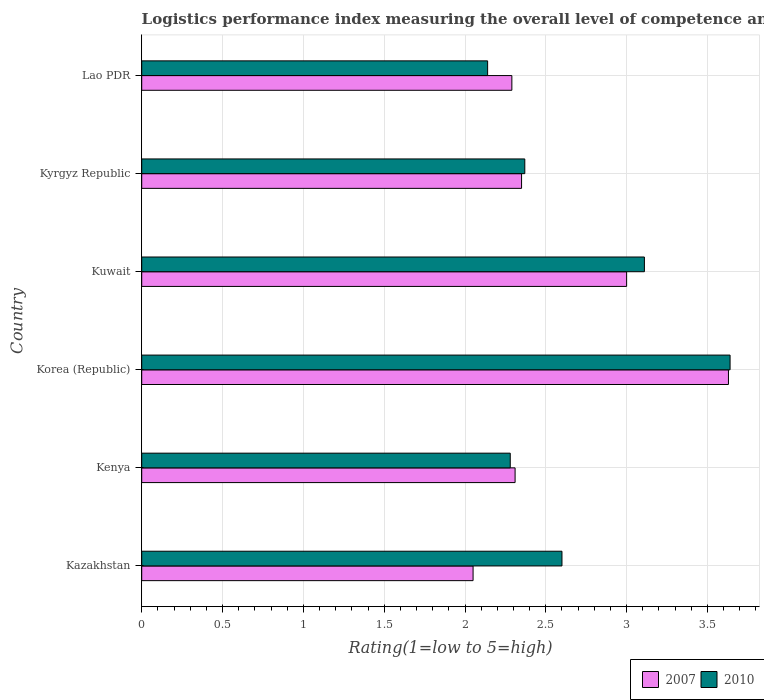How many different coloured bars are there?
Give a very brief answer. 2. Are the number of bars per tick equal to the number of legend labels?
Ensure brevity in your answer.  Yes. Are the number of bars on each tick of the Y-axis equal?
Your response must be concise. Yes. How many bars are there on the 3rd tick from the top?
Offer a very short reply. 2. How many bars are there on the 2nd tick from the bottom?
Provide a short and direct response. 2. What is the label of the 2nd group of bars from the top?
Your response must be concise. Kyrgyz Republic. In how many cases, is the number of bars for a given country not equal to the number of legend labels?
Offer a very short reply. 0. What is the Logistic performance index in 2007 in Korea (Republic)?
Offer a terse response. 3.63. Across all countries, what is the maximum Logistic performance index in 2010?
Give a very brief answer. 3.64. Across all countries, what is the minimum Logistic performance index in 2010?
Your answer should be compact. 2.14. In which country was the Logistic performance index in 2007 minimum?
Provide a short and direct response. Kazakhstan. What is the total Logistic performance index in 2010 in the graph?
Make the answer very short. 16.14. What is the difference between the Logistic performance index in 2007 in Kazakhstan and that in Korea (Republic)?
Offer a very short reply. -1.58. What is the difference between the Logistic performance index in 2010 in Kuwait and the Logistic performance index in 2007 in Lao PDR?
Your answer should be very brief. 0.82. What is the average Logistic performance index in 2010 per country?
Make the answer very short. 2.69. What is the difference between the Logistic performance index in 2007 and Logistic performance index in 2010 in Lao PDR?
Make the answer very short. 0.15. In how many countries, is the Logistic performance index in 2010 greater than 2.6 ?
Provide a short and direct response. 2. What is the ratio of the Logistic performance index in 2010 in Korea (Republic) to that in Kuwait?
Offer a terse response. 1.17. Is the difference between the Logistic performance index in 2007 in Korea (Republic) and Kuwait greater than the difference between the Logistic performance index in 2010 in Korea (Republic) and Kuwait?
Ensure brevity in your answer.  Yes. What is the difference between the highest and the second highest Logistic performance index in 2007?
Give a very brief answer. 0.63. What does the 1st bar from the top in Kenya represents?
Give a very brief answer. 2010. What does the 1st bar from the bottom in Lao PDR represents?
Make the answer very short. 2007. Are all the bars in the graph horizontal?
Give a very brief answer. Yes. Where does the legend appear in the graph?
Offer a terse response. Bottom right. What is the title of the graph?
Give a very brief answer. Logistics performance index measuring the overall level of competence and quality of logistics services. What is the label or title of the X-axis?
Ensure brevity in your answer.  Rating(1=low to 5=high). What is the Rating(1=low to 5=high) of 2007 in Kazakhstan?
Ensure brevity in your answer.  2.05. What is the Rating(1=low to 5=high) in 2007 in Kenya?
Provide a short and direct response. 2.31. What is the Rating(1=low to 5=high) in 2010 in Kenya?
Your answer should be very brief. 2.28. What is the Rating(1=low to 5=high) in 2007 in Korea (Republic)?
Ensure brevity in your answer.  3.63. What is the Rating(1=low to 5=high) in 2010 in Korea (Republic)?
Provide a short and direct response. 3.64. What is the Rating(1=low to 5=high) of 2007 in Kuwait?
Offer a very short reply. 3. What is the Rating(1=low to 5=high) of 2010 in Kuwait?
Ensure brevity in your answer.  3.11. What is the Rating(1=low to 5=high) of 2007 in Kyrgyz Republic?
Give a very brief answer. 2.35. What is the Rating(1=low to 5=high) of 2010 in Kyrgyz Republic?
Your response must be concise. 2.37. What is the Rating(1=low to 5=high) in 2007 in Lao PDR?
Your answer should be very brief. 2.29. What is the Rating(1=low to 5=high) in 2010 in Lao PDR?
Your response must be concise. 2.14. Across all countries, what is the maximum Rating(1=low to 5=high) of 2007?
Provide a succinct answer. 3.63. Across all countries, what is the maximum Rating(1=low to 5=high) in 2010?
Make the answer very short. 3.64. Across all countries, what is the minimum Rating(1=low to 5=high) in 2007?
Make the answer very short. 2.05. Across all countries, what is the minimum Rating(1=low to 5=high) in 2010?
Keep it short and to the point. 2.14. What is the total Rating(1=low to 5=high) in 2007 in the graph?
Provide a succinct answer. 15.63. What is the total Rating(1=low to 5=high) in 2010 in the graph?
Your response must be concise. 16.14. What is the difference between the Rating(1=low to 5=high) in 2007 in Kazakhstan and that in Kenya?
Your answer should be compact. -0.26. What is the difference between the Rating(1=low to 5=high) of 2010 in Kazakhstan and that in Kenya?
Ensure brevity in your answer.  0.32. What is the difference between the Rating(1=low to 5=high) in 2007 in Kazakhstan and that in Korea (Republic)?
Your answer should be compact. -1.58. What is the difference between the Rating(1=low to 5=high) in 2010 in Kazakhstan and that in Korea (Republic)?
Offer a very short reply. -1.04. What is the difference between the Rating(1=low to 5=high) in 2007 in Kazakhstan and that in Kuwait?
Give a very brief answer. -0.95. What is the difference between the Rating(1=low to 5=high) of 2010 in Kazakhstan and that in Kuwait?
Give a very brief answer. -0.51. What is the difference between the Rating(1=low to 5=high) of 2010 in Kazakhstan and that in Kyrgyz Republic?
Your answer should be compact. 0.23. What is the difference between the Rating(1=low to 5=high) in 2007 in Kazakhstan and that in Lao PDR?
Offer a terse response. -0.24. What is the difference between the Rating(1=low to 5=high) of 2010 in Kazakhstan and that in Lao PDR?
Offer a very short reply. 0.46. What is the difference between the Rating(1=low to 5=high) in 2007 in Kenya and that in Korea (Republic)?
Provide a succinct answer. -1.32. What is the difference between the Rating(1=low to 5=high) in 2010 in Kenya and that in Korea (Republic)?
Keep it short and to the point. -1.36. What is the difference between the Rating(1=low to 5=high) of 2007 in Kenya and that in Kuwait?
Your response must be concise. -0.69. What is the difference between the Rating(1=low to 5=high) of 2010 in Kenya and that in Kuwait?
Offer a very short reply. -0.83. What is the difference between the Rating(1=low to 5=high) in 2007 in Kenya and that in Kyrgyz Republic?
Your answer should be very brief. -0.04. What is the difference between the Rating(1=low to 5=high) of 2010 in Kenya and that in Kyrgyz Republic?
Offer a very short reply. -0.09. What is the difference between the Rating(1=low to 5=high) of 2010 in Kenya and that in Lao PDR?
Keep it short and to the point. 0.14. What is the difference between the Rating(1=low to 5=high) of 2007 in Korea (Republic) and that in Kuwait?
Give a very brief answer. 0.63. What is the difference between the Rating(1=low to 5=high) in 2010 in Korea (Republic) and that in Kuwait?
Keep it short and to the point. 0.53. What is the difference between the Rating(1=low to 5=high) of 2007 in Korea (Republic) and that in Kyrgyz Republic?
Your answer should be very brief. 1.28. What is the difference between the Rating(1=low to 5=high) in 2010 in Korea (Republic) and that in Kyrgyz Republic?
Give a very brief answer. 1.27. What is the difference between the Rating(1=low to 5=high) of 2007 in Korea (Republic) and that in Lao PDR?
Offer a terse response. 1.34. What is the difference between the Rating(1=low to 5=high) of 2010 in Korea (Republic) and that in Lao PDR?
Make the answer very short. 1.5. What is the difference between the Rating(1=low to 5=high) of 2007 in Kuwait and that in Kyrgyz Republic?
Your answer should be compact. 0.65. What is the difference between the Rating(1=low to 5=high) of 2010 in Kuwait and that in Kyrgyz Republic?
Give a very brief answer. 0.74. What is the difference between the Rating(1=low to 5=high) of 2007 in Kuwait and that in Lao PDR?
Provide a succinct answer. 0.71. What is the difference between the Rating(1=low to 5=high) in 2007 in Kyrgyz Republic and that in Lao PDR?
Offer a very short reply. 0.06. What is the difference between the Rating(1=low to 5=high) in 2010 in Kyrgyz Republic and that in Lao PDR?
Give a very brief answer. 0.23. What is the difference between the Rating(1=low to 5=high) of 2007 in Kazakhstan and the Rating(1=low to 5=high) of 2010 in Kenya?
Ensure brevity in your answer.  -0.23. What is the difference between the Rating(1=low to 5=high) in 2007 in Kazakhstan and the Rating(1=low to 5=high) in 2010 in Korea (Republic)?
Your response must be concise. -1.59. What is the difference between the Rating(1=low to 5=high) of 2007 in Kazakhstan and the Rating(1=low to 5=high) of 2010 in Kuwait?
Ensure brevity in your answer.  -1.06. What is the difference between the Rating(1=low to 5=high) in 2007 in Kazakhstan and the Rating(1=low to 5=high) in 2010 in Kyrgyz Republic?
Offer a very short reply. -0.32. What is the difference between the Rating(1=low to 5=high) in 2007 in Kazakhstan and the Rating(1=low to 5=high) in 2010 in Lao PDR?
Keep it short and to the point. -0.09. What is the difference between the Rating(1=low to 5=high) in 2007 in Kenya and the Rating(1=low to 5=high) in 2010 in Korea (Republic)?
Offer a terse response. -1.33. What is the difference between the Rating(1=low to 5=high) of 2007 in Kenya and the Rating(1=low to 5=high) of 2010 in Kuwait?
Give a very brief answer. -0.8. What is the difference between the Rating(1=low to 5=high) of 2007 in Kenya and the Rating(1=low to 5=high) of 2010 in Kyrgyz Republic?
Keep it short and to the point. -0.06. What is the difference between the Rating(1=low to 5=high) of 2007 in Kenya and the Rating(1=low to 5=high) of 2010 in Lao PDR?
Ensure brevity in your answer.  0.17. What is the difference between the Rating(1=low to 5=high) in 2007 in Korea (Republic) and the Rating(1=low to 5=high) in 2010 in Kuwait?
Provide a short and direct response. 0.52. What is the difference between the Rating(1=low to 5=high) in 2007 in Korea (Republic) and the Rating(1=low to 5=high) in 2010 in Kyrgyz Republic?
Provide a succinct answer. 1.26. What is the difference between the Rating(1=low to 5=high) in 2007 in Korea (Republic) and the Rating(1=low to 5=high) in 2010 in Lao PDR?
Give a very brief answer. 1.49. What is the difference between the Rating(1=low to 5=high) in 2007 in Kuwait and the Rating(1=low to 5=high) in 2010 in Kyrgyz Republic?
Keep it short and to the point. 0.63. What is the difference between the Rating(1=low to 5=high) of 2007 in Kuwait and the Rating(1=low to 5=high) of 2010 in Lao PDR?
Offer a very short reply. 0.86. What is the difference between the Rating(1=low to 5=high) of 2007 in Kyrgyz Republic and the Rating(1=low to 5=high) of 2010 in Lao PDR?
Your answer should be very brief. 0.21. What is the average Rating(1=low to 5=high) in 2007 per country?
Offer a very short reply. 2.6. What is the average Rating(1=low to 5=high) of 2010 per country?
Ensure brevity in your answer.  2.69. What is the difference between the Rating(1=low to 5=high) of 2007 and Rating(1=low to 5=high) of 2010 in Kazakhstan?
Your answer should be very brief. -0.55. What is the difference between the Rating(1=low to 5=high) in 2007 and Rating(1=low to 5=high) in 2010 in Korea (Republic)?
Keep it short and to the point. -0.01. What is the difference between the Rating(1=low to 5=high) in 2007 and Rating(1=low to 5=high) in 2010 in Kuwait?
Your answer should be very brief. -0.11. What is the difference between the Rating(1=low to 5=high) of 2007 and Rating(1=low to 5=high) of 2010 in Kyrgyz Republic?
Ensure brevity in your answer.  -0.02. What is the difference between the Rating(1=low to 5=high) of 2007 and Rating(1=low to 5=high) of 2010 in Lao PDR?
Make the answer very short. 0.15. What is the ratio of the Rating(1=low to 5=high) of 2007 in Kazakhstan to that in Kenya?
Provide a succinct answer. 0.89. What is the ratio of the Rating(1=low to 5=high) of 2010 in Kazakhstan to that in Kenya?
Provide a succinct answer. 1.14. What is the ratio of the Rating(1=low to 5=high) of 2007 in Kazakhstan to that in Korea (Republic)?
Your response must be concise. 0.56. What is the ratio of the Rating(1=low to 5=high) of 2010 in Kazakhstan to that in Korea (Republic)?
Offer a very short reply. 0.71. What is the ratio of the Rating(1=low to 5=high) in 2007 in Kazakhstan to that in Kuwait?
Your response must be concise. 0.68. What is the ratio of the Rating(1=low to 5=high) of 2010 in Kazakhstan to that in Kuwait?
Provide a succinct answer. 0.84. What is the ratio of the Rating(1=low to 5=high) in 2007 in Kazakhstan to that in Kyrgyz Republic?
Your answer should be compact. 0.87. What is the ratio of the Rating(1=low to 5=high) of 2010 in Kazakhstan to that in Kyrgyz Republic?
Your answer should be compact. 1.1. What is the ratio of the Rating(1=low to 5=high) in 2007 in Kazakhstan to that in Lao PDR?
Provide a short and direct response. 0.9. What is the ratio of the Rating(1=low to 5=high) of 2010 in Kazakhstan to that in Lao PDR?
Your response must be concise. 1.22. What is the ratio of the Rating(1=low to 5=high) of 2007 in Kenya to that in Korea (Republic)?
Your answer should be compact. 0.64. What is the ratio of the Rating(1=low to 5=high) in 2010 in Kenya to that in Korea (Republic)?
Provide a succinct answer. 0.63. What is the ratio of the Rating(1=low to 5=high) in 2007 in Kenya to that in Kuwait?
Your answer should be very brief. 0.77. What is the ratio of the Rating(1=low to 5=high) of 2010 in Kenya to that in Kuwait?
Provide a short and direct response. 0.73. What is the ratio of the Rating(1=low to 5=high) of 2007 in Kenya to that in Kyrgyz Republic?
Provide a short and direct response. 0.98. What is the ratio of the Rating(1=low to 5=high) in 2007 in Kenya to that in Lao PDR?
Provide a short and direct response. 1.01. What is the ratio of the Rating(1=low to 5=high) in 2010 in Kenya to that in Lao PDR?
Provide a short and direct response. 1.07. What is the ratio of the Rating(1=low to 5=high) of 2007 in Korea (Republic) to that in Kuwait?
Offer a terse response. 1.21. What is the ratio of the Rating(1=low to 5=high) of 2010 in Korea (Republic) to that in Kuwait?
Your answer should be very brief. 1.17. What is the ratio of the Rating(1=low to 5=high) of 2007 in Korea (Republic) to that in Kyrgyz Republic?
Your answer should be compact. 1.54. What is the ratio of the Rating(1=low to 5=high) of 2010 in Korea (Republic) to that in Kyrgyz Republic?
Your answer should be compact. 1.54. What is the ratio of the Rating(1=low to 5=high) of 2007 in Korea (Republic) to that in Lao PDR?
Give a very brief answer. 1.59. What is the ratio of the Rating(1=low to 5=high) of 2010 in Korea (Republic) to that in Lao PDR?
Give a very brief answer. 1.7. What is the ratio of the Rating(1=low to 5=high) of 2007 in Kuwait to that in Kyrgyz Republic?
Your answer should be very brief. 1.28. What is the ratio of the Rating(1=low to 5=high) in 2010 in Kuwait to that in Kyrgyz Republic?
Ensure brevity in your answer.  1.31. What is the ratio of the Rating(1=low to 5=high) of 2007 in Kuwait to that in Lao PDR?
Ensure brevity in your answer.  1.31. What is the ratio of the Rating(1=low to 5=high) of 2010 in Kuwait to that in Lao PDR?
Offer a terse response. 1.45. What is the ratio of the Rating(1=low to 5=high) in 2007 in Kyrgyz Republic to that in Lao PDR?
Make the answer very short. 1.03. What is the ratio of the Rating(1=low to 5=high) in 2010 in Kyrgyz Republic to that in Lao PDR?
Ensure brevity in your answer.  1.11. What is the difference between the highest and the second highest Rating(1=low to 5=high) of 2007?
Your response must be concise. 0.63. What is the difference between the highest and the second highest Rating(1=low to 5=high) of 2010?
Make the answer very short. 0.53. What is the difference between the highest and the lowest Rating(1=low to 5=high) in 2007?
Make the answer very short. 1.58. What is the difference between the highest and the lowest Rating(1=low to 5=high) of 2010?
Give a very brief answer. 1.5. 